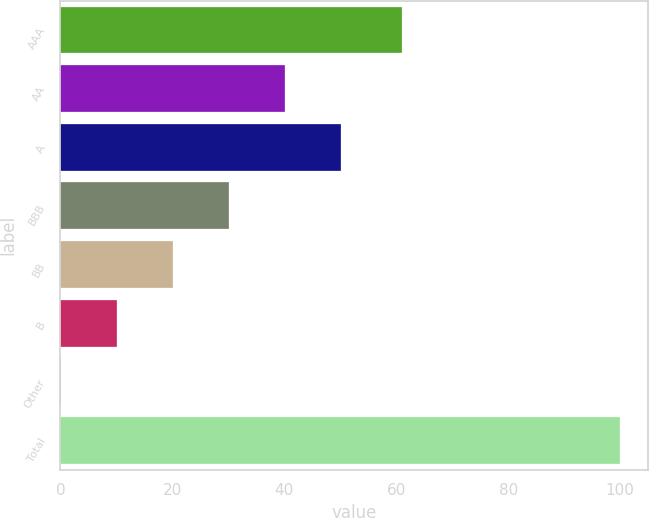Convert chart. <chart><loc_0><loc_0><loc_500><loc_500><bar_chart><fcel>AAA<fcel>AA<fcel>A<fcel>BBB<fcel>BB<fcel>B<fcel>Other<fcel>Total<nl><fcel>61.1<fcel>40.06<fcel>50.05<fcel>30.07<fcel>20.08<fcel>10.09<fcel>0.1<fcel>100<nl></chart> 